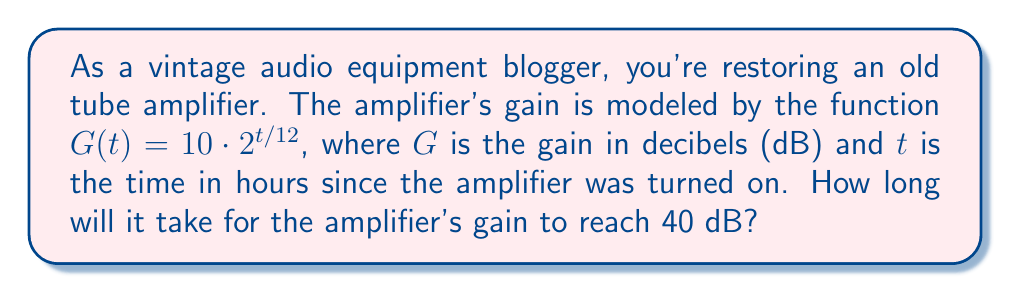Teach me how to tackle this problem. To solve this problem, we need to use the properties of exponential functions and logarithms. Let's approach this step-by-step:

1) We're given the function $G(t) = 10 \cdot 2^{t/12}$, and we want to find $t$ when $G(t) = 40$.

2) Let's set up the equation:
   $40 = 10 \cdot 2^{t/12}$

3) First, divide both sides by 10:
   $4 = 2^{t/12}$

4) Now, we can use logarithms to solve for $t$. Let's use log base 2 on both sides:
   $\log_2(4) = \log_2(2^{t/12})$

5) The left side simplifies to 2 (since $2^2 = 4$), and on the right side, we can use the logarithm property $\log_a(a^x) = x$:
   $2 = t/12$

6) Finally, multiply both sides by 12:
   $24 = t$

Therefore, it will take 24 hours for the amplifier's gain to reach 40 dB.
Answer: $t = 24$ hours 